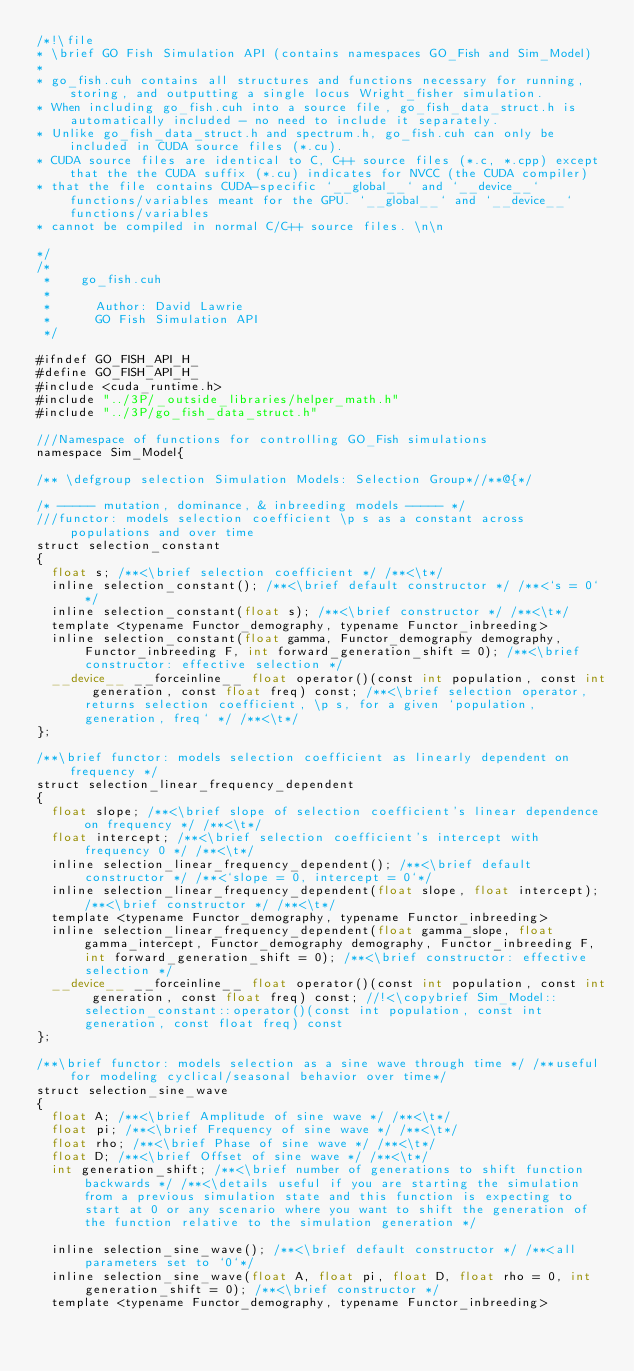<code> <loc_0><loc_0><loc_500><loc_500><_Cuda_>/*!\file
* \brief GO Fish Simulation API (contains namespaces GO_Fish and Sim_Model)
*
* go_fish.cuh contains all structures and functions necessary for running, storing, and outputting a single locus Wright_fisher simulation.
* When including go_fish.cuh into a source file, go_fish_data_struct.h is automatically included - no need to include it separately.
* Unlike go_fish_data_struct.h and spectrum.h, go_fish.cuh can only be included in CUDA source files (*.cu).
* CUDA source files are identical to C, C++ source files (*.c, *.cpp) except that the the CUDA suffix (*.cu) indicates for NVCC (the CUDA compiler)
* that the file contains CUDA-specific `__global__` and `__device__` functions/variables meant for the GPU. `__global__` and `__device__` functions/variables
* cannot be compiled in normal C/C++ source files. \n\n

*/
/*
 * 		go_fish.cuh
 *
 *      Author: David Lawrie
 *      GO Fish Simulation API
 */

#ifndef GO_FISH_API_H_
#define GO_FISH_API_H_
#include <cuda_runtime.h>
#include "../3P/_outside_libraries/helper_math.h"
#include "../3P/go_fish_data_struct.h"

///Namespace of functions for controlling GO_Fish simulations
namespace Sim_Model{

/** \defgroup selection Simulation Models: Selection Group*//**@{*/

/* ----- mutation, dominance, & inbreeding models ----- */
///functor: models selection coefficient \p s as a constant across populations and over time
struct selection_constant
{
	float s; /**<\brief selection coefficient */ /**<\t*/
	inline selection_constant(); /**<\brief default constructor */ /**<`s = 0`*/
	inline selection_constant(float s); /**<\brief constructor */ /**<\t*/
	template <typename Functor_demography, typename Functor_inbreeding>
	inline selection_constant(float gamma, Functor_demography demography, Functor_inbreeding F, int forward_generation_shift = 0); /**<\brief constructor: effective selection */
	__device__ __forceinline__ float operator()(const int population, const int generation, const float freq) const; /**<\brief selection operator, returns selection coefficient, \p s, for a given `population, generation, freq` */ /**<\t*/
};

/**\brief functor: models selection coefficient as linearly dependent on frequency */
struct selection_linear_frequency_dependent
{
	float slope; /**<\brief slope of selection coefficient's linear dependence on frequency */ /**<\t*/
	float intercept; /**<\brief selection coefficient's intercept with frequency 0 */ /**<\t*/
	inline selection_linear_frequency_dependent(); /**<\brief default constructor */ /**<`slope = 0, intercept = 0`*/
	inline selection_linear_frequency_dependent(float slope, float intercept); /**<\brief constructor */ /**<\t*/
	template <typename Functor_demography, typename Functor_inbreeding>
	inline selection_linear_frequency_dependent(float gamma_slope, float gamma_intercept, Functor_demography demography, Functor_inbreeding F, int forward_generation_shift = 0); /**<\brief constructor: effective selection */
	__device__ __forceinline__ float operator()(const int population, const int generation, const float freq) const; //!<\copybrief Sim_Model::selection_constant::operator()(const int population, const int generation, const float freq) const
};

/**\brief functor: models selection as a sine wave through time */ /**useful for modeling cyclical/seasonal behavior over time*/
struct selection_sine_wave
{
	float A; /**<\brief Amplitude of sine wave */ /**<\t*/
	float pi; /**<\brief Frequency of sine wave */ /**<\t*/
	float rho; /**<\brief Phase of sine wave */ /**<\t*/
	float D; /**<\brief Offset of sine wave */ /**<\t*/
	int generation_shift; /**<\brief number of generations to shift function backwards */ /**<\details useful if you are starting the simulation from a previous simulation state and this function is expecting to start at 0 or any scenario where you want to shift the generation of the function relative to the simulation generation */

	inline selection_sine_wave(); /**<\brief default constructor */ /**<all parameters set to `0`*/
	inline selection_sine_wave(float A, float pi, float D, float rho = 0, int generation_shift = 0); /**<\brief constructor */
	template <typename Functor_demography, typename Functor_inbreeding></code> 